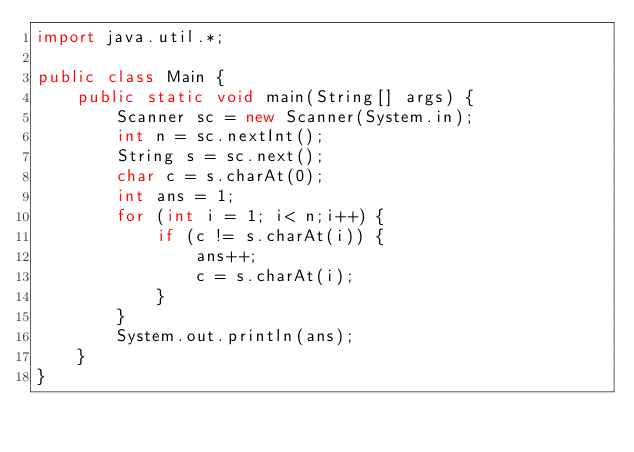<code> <loc_0><loc_0><loc_500><loc_500><_Java_>import java.util.*;

public class Main {
    public static void main(String[] args) {
        Scanner sc = new Scanner(System.in);
        int n = sc.nextInt();
        String s = sc.next();
        char c = s.charAt(0);
        int ans = 1;
        for (int i = 1; i< n;i++) {
            if (c != s.charAt(i)) {
                ans++;
                c = s.charAt(i);
            }
        }
        System.out.println(ans);
    }
}
</code> 